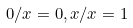Convert formula to latex. <formula><loc_0><loc_0><loc_500><loc_500>0 / x = 0 , x / x = 1</formula> 